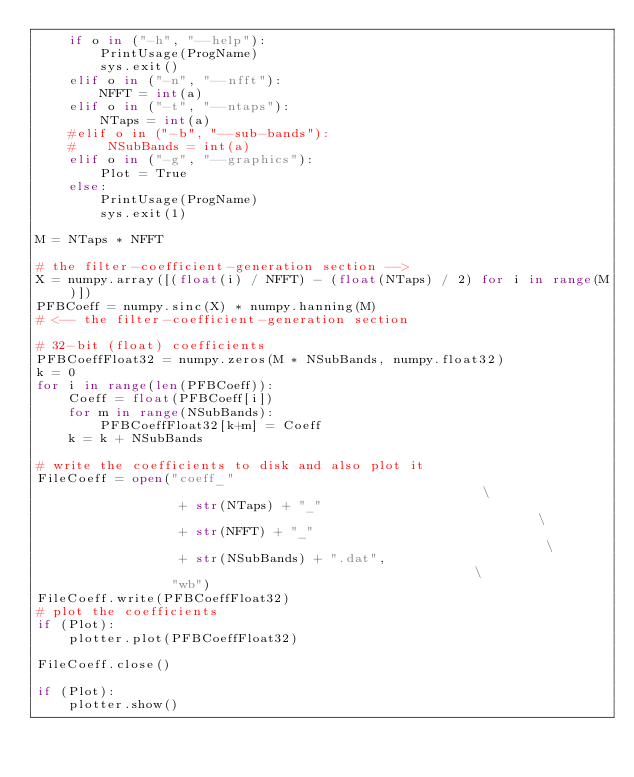<code> <loc_0><loc_0><loc_500><loc_500><_Python_>    if o in ("-h", "--help"):
        PrintUsage(ProgName)
        sys.exit()
    elif o in ("-n", "--nfft"):
        NFFT = int(a)
    elif o in ("-t", "--ntaps"):
        NTaps = int(a)
    #elif o in ("-b", "--sub-bands"):
    #    NSubBands = int(a)
    elif o in ("-g", "--graphics"):
        Plot = True
    else:
        PrintUsage(ProgName)
        sys.exit(1)

M = NTaps * NFFT

# the filter-coefficient-generation section -->
X = numpy.array([(float(i) / NFFT) - (float(NTaps) / 2) for i in range(M)])
PFBCoeff = numpy.sinc(X) * numpy.hanning(M)
# <-- the filter-coefficient-generation section

# 32-bit (float) coefficients
PFBCoeffFloat32 = numpy.zeros(M * NSubBands, numpy.float32)
k = 0
for i in range(len(PFBCoeff)):
    Coeff = float(PFBCoeff[i])
    for m in range(NSubBands):
        PFBCoeffFloat32[k+m] = Coeff
    k = k + NSubBands

# write the coefficients to disk and also plot it
FileCoeff = open("coeff_"                                                     \
                  + str(NTaps) + "_"                                          \
                  + str(NFFT) + "_"                                           \
                  + str(NSubBands) + ".dat",                                  \
                 "wb")
FileCoeff.write(PFBCoeffFloat32)
# plot the coefficients
if (Plot):
    plotter.plot(PFBCoeffFloat32)

FileCoeff.close()

if (Plot):
    plotter.show()

</code> 